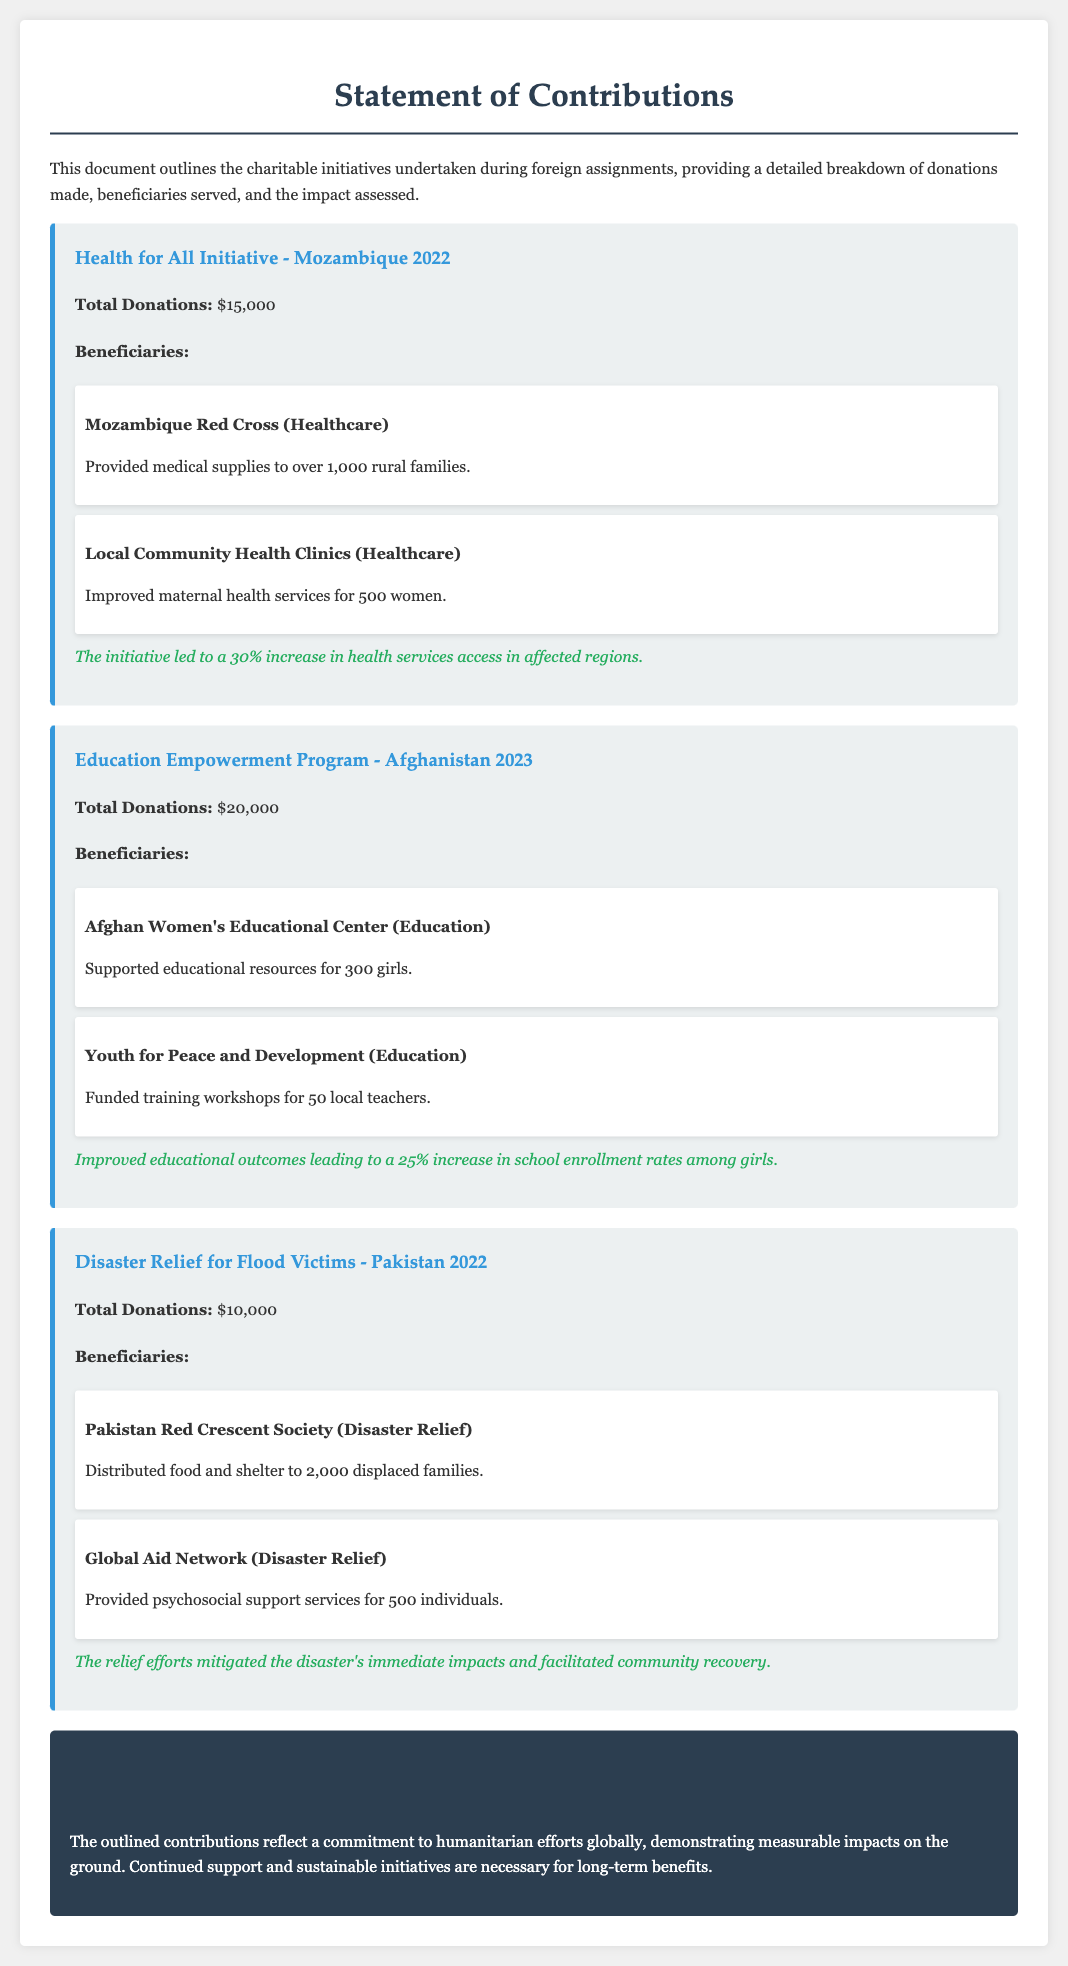What is the total donation for the Health for All Initiative? The total donation is specified for each initiative, with the Health for All Initiative receiving $15,000.
Answer: $15,000 How many beneficiaries did the Mozambique Red Cross serve? The document states that the Mozambique Red Cross provided medical supplies to over 1,000 rural families.
Answer: Over 1,000 What was the focus of the Education Empowerment Program? The program aimed to improve educational resources and training within Afghanistan, specifically for girls and local teachers.
Answer: Education How much total funding was allocated to the Disaster Relief for Flood Victims initiative? The document details that the total donations for the Disaster Relief for Flood Victims initiative amounted to $10,000.
Answer: $10,000 What percentage increase in health services access was reported in Mozambique? A 30% increase in health services access in affected regions was noted as an impact of the initiative.
Answer: 30% Which organization supported educational resources for 300 girls in Afghanistan? The Afghan Women's Educational Center is mentioned as the beneficiary that received support for this purpose.
Answer: Afghan Women's Educational Center How many local teachers benefited from training workshops funded by the initiative in Afghanistan? The initiative's funding provided training workshops for 50 local teachers.
Answer: 50 What impact did the disaster relief efforts have on community recovery in Pakistan? The relief efforts are described as having mitigated immediate impacts and facilitated community recovery.
Answer: Community recovery What year did the Health for All Initiative take place? The document indicates that this initiative was undertaken in Mozambique in 2022.
Answer: 2022 